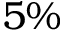Convert formula to latex. <formula><loc_0><loc_0><loc_500><loc_500>5 \%</formula> 